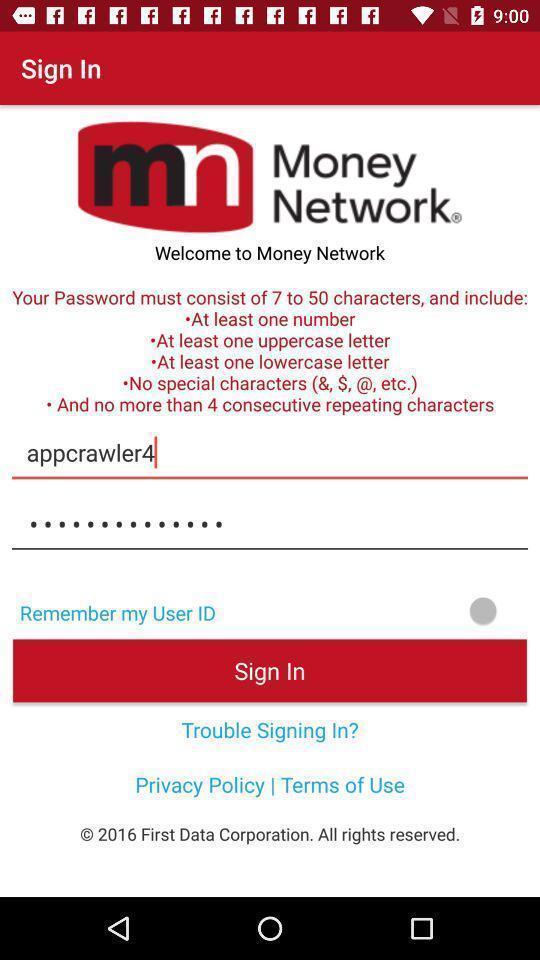Explain the elements present in this screenshot. Welcome page for money tracker app. 